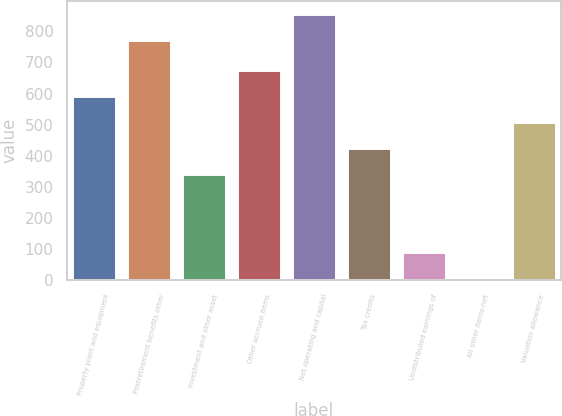Convert chart. <chart><loc_0><loc_0><loc_500><loc_500><bar_chart><fcel>Property plant and equipment<fcel>Postretirement benefits other<fcel>Investment and other asset<fcel>Other accrued items<fcel>Net operating and capital<fcel>Tax credits<fcel>Undistributed earnings of<fcel>All other items-net<fcel>Valuation allowance<nl><fcel>591.9<fcel>771<fcel>342<fcel>675.2<fcel>854.3<fcel>425.3<fcel>91.3<fcel>8<fcel>508.6<nl></chart> 